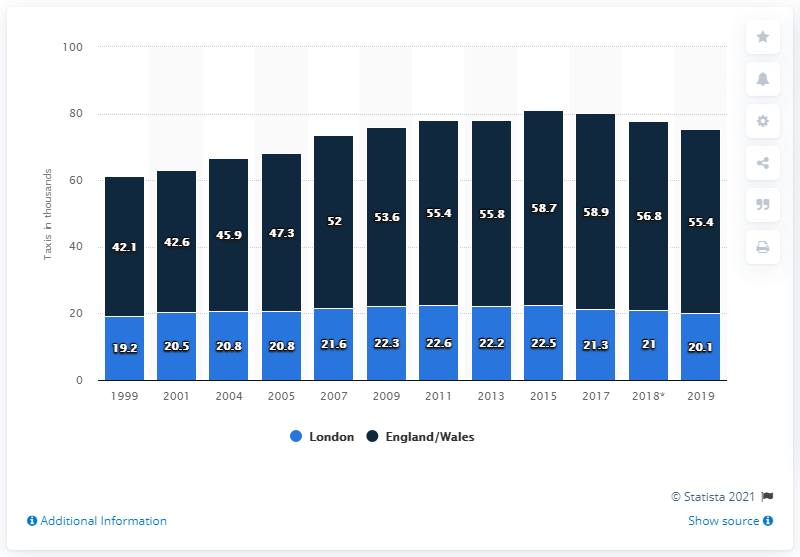Mention a couple of crucial points in this snapshot. In 2019, there were 20,100 licensed taxis operating in London. The total for the rest of England and Wales in 2019 was 55.4. In 2017, there was a significant increase in the number of taxis both within and outside of London. 